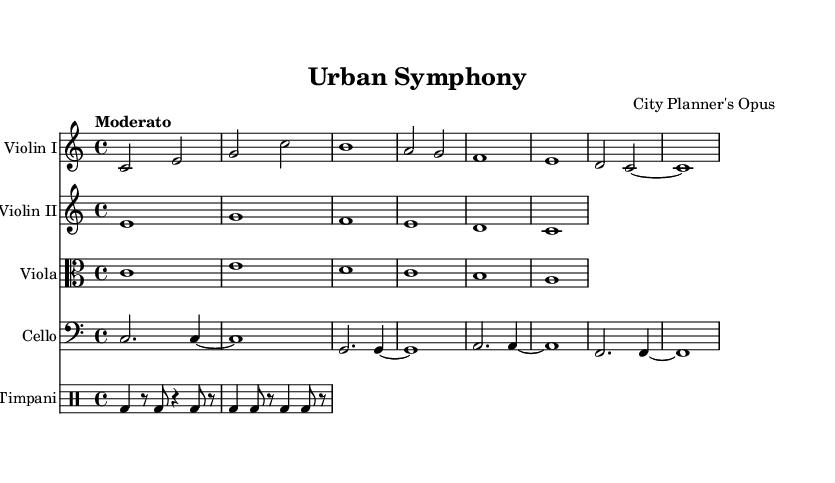What is the key signature of this music? The key signature is indicated at the beginning of the score. In this case, it shows C major, which has no sharps or flats.
Answer: C major What is the time signature of this music? The time signature is found at the beginning of the score, showing the number of beats in each measure. Here, it is 4/4, meaning there are four beats per measure.
Answer: 4/4 What is the tempo marking of this music? The tempo marking is specified in the score and indicates the speed of the music. In this case, the term "Moderato" suggests a moderate pace.
Answer: Moderato How many instruments are in this score? To determine the number of instruments, count the distinct staves in the score. There are five staves: one each for Violin I, Violin II, Viola, Cello, and Timpani.
Answer: Five What is the highest note in the Violin I part? To find the highest note, examine the notes in the Violin I part. The highest note in this part is B.
Answer: B For which type of performance is this music intended? This score is labeled as "Urban Symphony" and is likely intended for orchestral performance, typically indicative of a film score.
Answer: Orchestral What rhythmic pattern is used in the Timpani part? The Timpani part features a repeated pattern of notes with rests, indicated by the notation. It uses quarter notes and eight notes in a specific rhythmic sequence.
Answer: Alternating quarter and eighth notes 